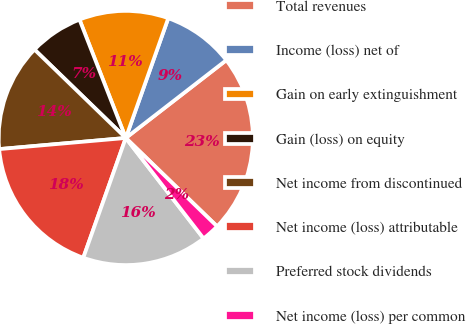<chart> <loc_0><loc_0><loc_500><loc_500><pie_chart><fcel>Total revenues<fcel>Income (loss) net of<fcel>Gain on early extinguishment<fcel>Gain (loss) on equity<fcel>Net income from discontinued<fcel>Net income (loss) attributable<fcel>Preferred stock dividends<fcel>Net income (loss) per common<nl><fcel>22.73%<fcel>9.09%<fcel>11.36%<fcel>6.82%<fcel>13.64%<fcel>18.18%<fcel>15.91%<fcel>2.27%<nl></chart> 